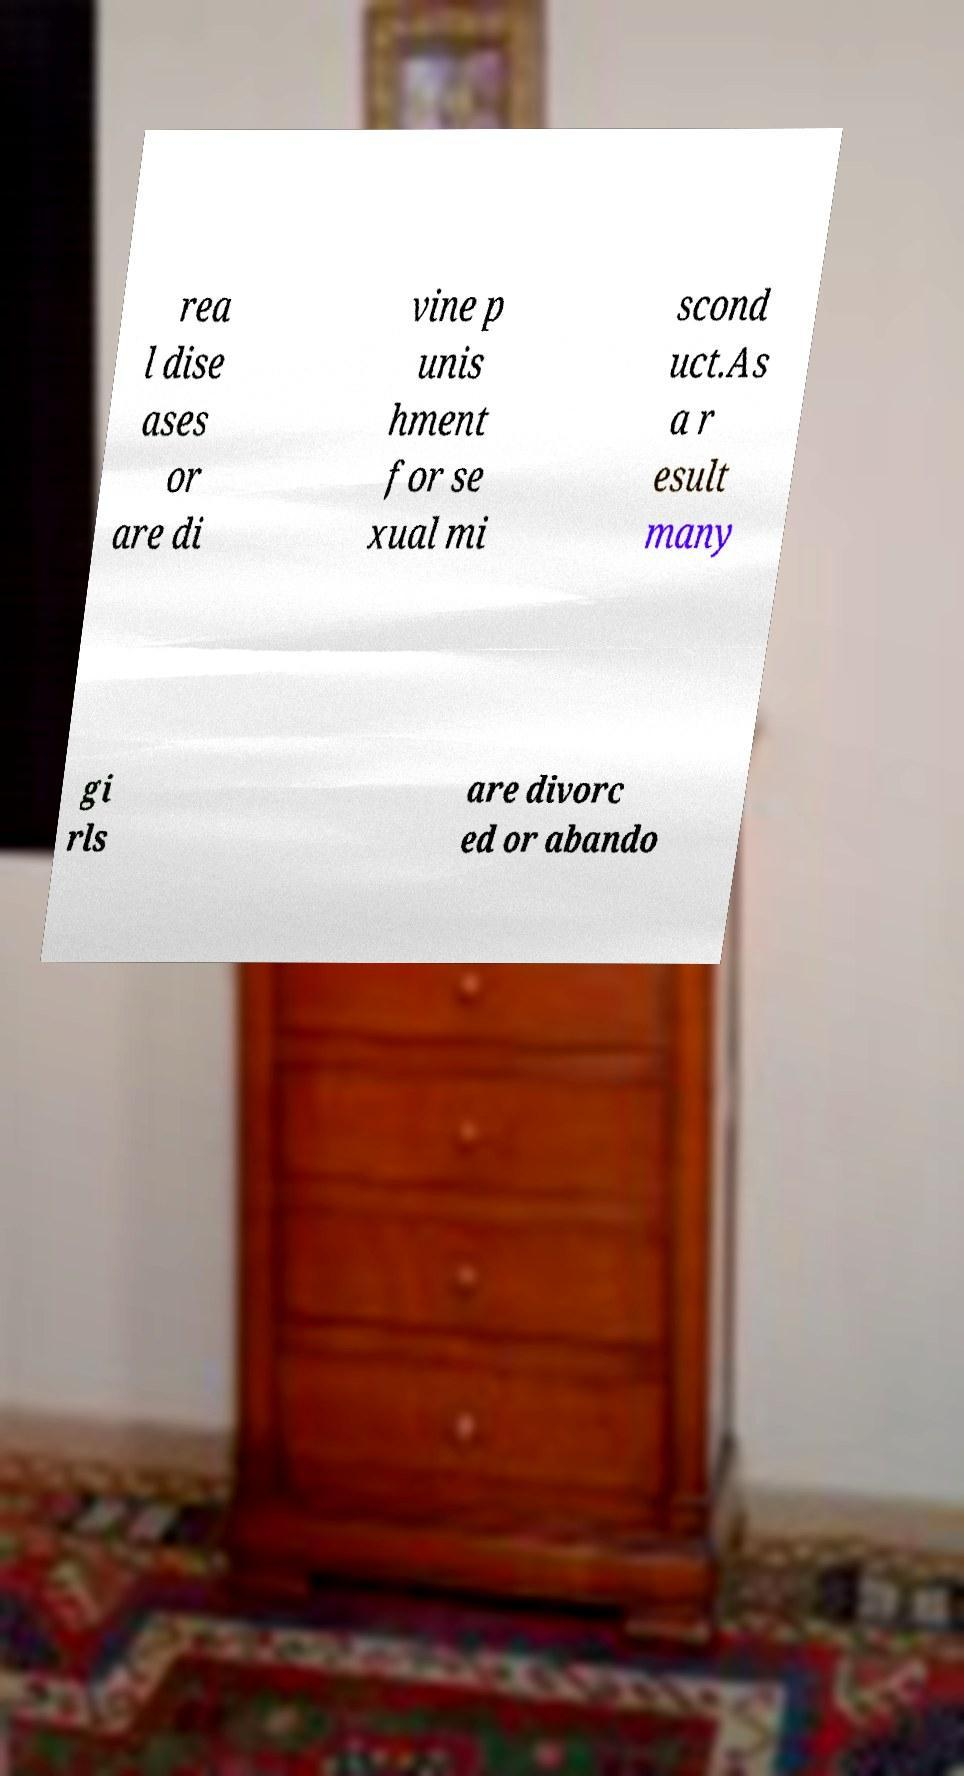For documentation purposes, I need the text within this image transcribed. Could you provide that? rea l dise ases or are di vine p unis hment for se xual mi scond uct.As a r esult many gi rls are divorc ed or abando 